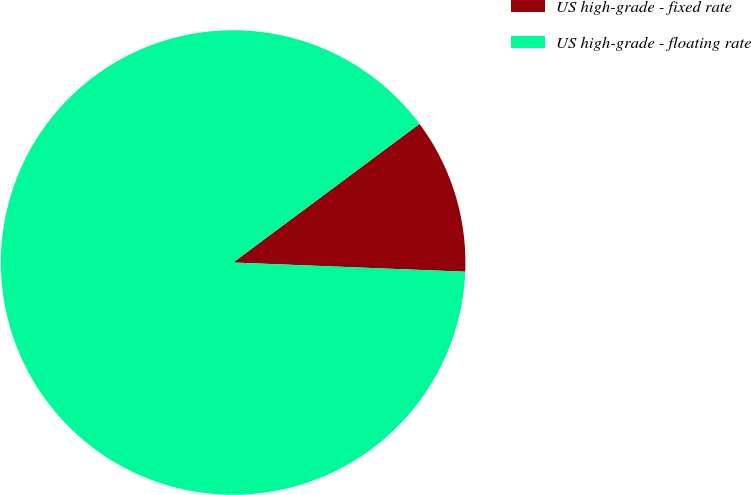Convert chart. <chart><loc_0><loc_0><loc_500><loc_500><pie_chart><fcel>US high-grade - fixed rate<fcel>US high-grade - floating rate<nl><fcel>10.81%<fcel>89.19%<nl></chart> 